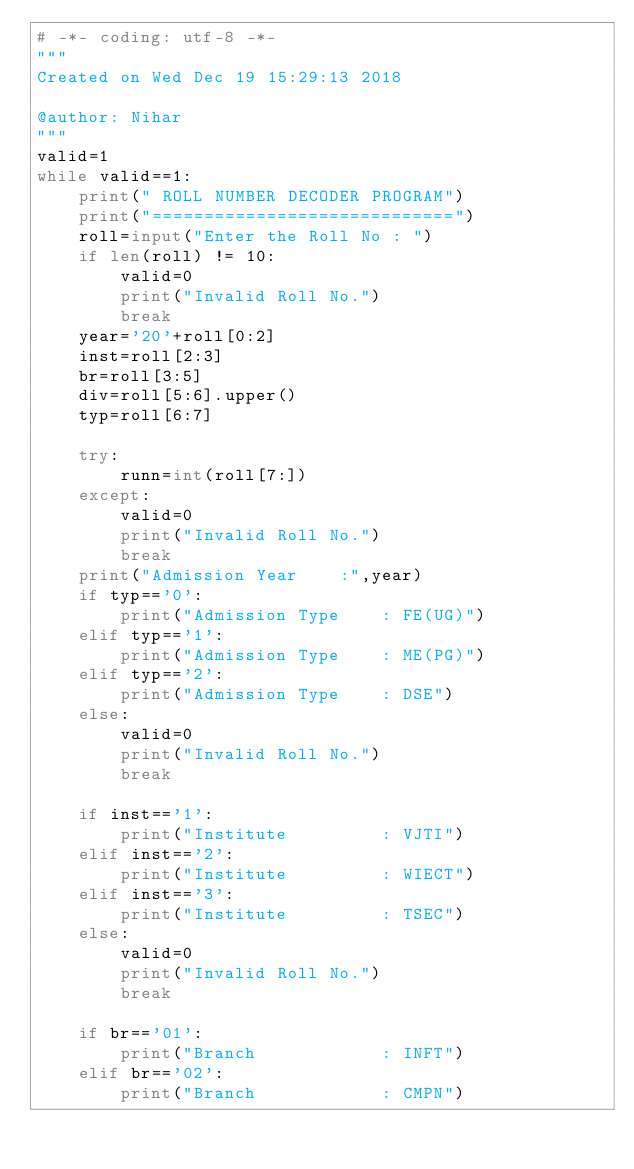<code> <loc_0><loc_0><loc_500><loc_500><_Python_># -*- coding: utf-8 -*-
"""
Created on Wed Dec 19 15:29:13 2018

@author: Nihar
"""
valid=1
while valid==1:
    print(" ROLL NUMBER DECODER PROGRAM")
    print("=============================")
    roll=input("Enter the Roll No : ")
    if len(roll) != 10:
        valid=0
        print("Invalid Roll No.")
        break
    year='20'+roll[0:2]
    inst=roll[2:3]
    br=roll[3:5]
    div=roll[5:6].upper()
    typ=roll[6:7]

    try:
        runn=int(roll[7:])
    except:
        valid=0
        print("Invalid Roll No.")
        break
    print("Admission Year    :",year)
    if typ=='0':
        print("Admission Type    : FE(UG)")
    elif typ=='1':
        print("Admission Type    : ME(PG)")
    elif typ=='2':
        print("Admission Type    : DSE")
    else:
        valid=0
        print("Invalid Roll No.")
        break

    if inst=='1':
        print("Institute         : VJTI")
    elif inst=='2':
        print("Institute         : WIECT")
    elif inst=='3':
        print("Institute         : TSEC")
    else:
        valid=0
        print("Invalid Roll No.")
        break

    if br=='01':
        print("Branch            : INFT")
    elif br=='02':
        print("Branch            : CMPN")</code> 